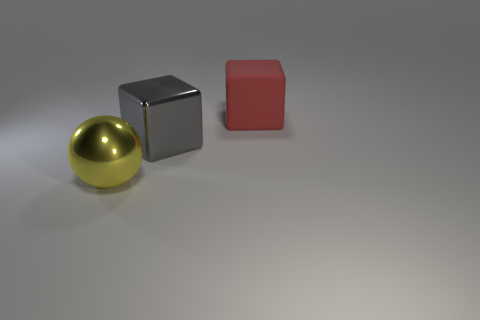Are there more yellow shiny objects right of the metal cube than large balls that are behind the large matte object?
Provide a succinct answer. No. There is a big rubber object that is the same shape as the gray shiny thing; what color is it?
Make the answer very short. Red. Is there anything else that has the same shape as the large rubber object?
Offer a very short reply. Yes. There is a big yellow object; is its shape the same as the big metallic thing behind the yellow sphere?
Offer a terse response. No. How many other things are made of the same material as the gray thing?
Your answer should be very brief. 1. What is the material of the big object behind the metallic cube?
Provide a short and direct response. Rubber. Is there a rubber block of the same color as the large ball?
Offer a terse response. No. There is a sphere that is the same size as the rubber thing; what is its color?
Provide a succinct answer. Yellow. How many big things are matte objects or metallic cubes?
Give a very brief answer. 2. Are there the same number of things that are right of the yellow metal sphere and gray cubes that are on the left side of the gray metal cube?
Provide a succinct answer. No. 